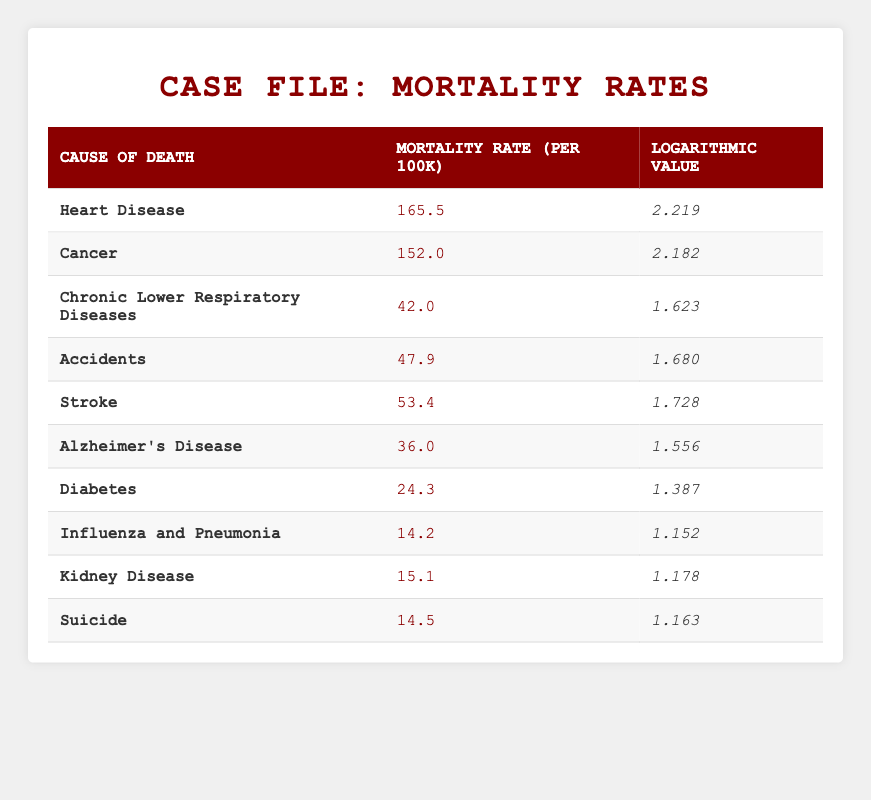What is the mortality rate for Heart Disease? The table lists the mortality rate for Heart Disease under the "Mortality Rate (per 100k)" column, which shows a value of 165.5.
Answer: 165.5 Which cause of death has the lowest mortality rate? By examining the "Mortality Rate (per 100k)" column, the lowest value is 14.2, which corresponds to Influenza and Pneumonia.
Answer: Influenza and Pneumonia Is the mortality rate for Cancer higher than that for Chronic Lower Respiratory Diseases? Yes, the table shows a mortality rate of 152.0 for Cancer and 42.0 for Chronic Lower Respiratory Diseases, indicating Cancer has a higher rate.
Answer: Yes What is the difference in mortality rates between Accidents and Stroke? The mortality rate for Accidents is 47.9 and for Stroke is 53.4. The difference is calculated as 53.4 - 47.9 = 5.5.
Answer: 5.5 What is the average mortality rate for Alzheimer's Disease and Kidney Disease? The rates for Alzheimer's Disease and Kidney Disease are 36.0 and 15.1, respectively. To find the average, the sum is 36.0 + 15.1 = 51.1, and then divided by 2 gives 51.1 / 2 = 25.55.
Answer: 25.55 Which cause of death has a logarithmic value greater than 1.7? Looking at the "Logarithmic Value" column, the causes Heart Disease (2.219), Cancer (2.182), and Stroke (1.728) have values greater than 1.7.
Answer: Heart Disease, Cancer, Stroke What is the cause of death with a mortality rate closest to 15? By checking the "Mortality Rate (per 100k)" column, Kidney Disease (15.1) is the closest to 15 when comparing all values listed.
Answer: Kidney Disease Is the combined mortality rate for Diabetes and Alzheimer's Disease greater than 60? The mortality rates for Diabetes and Alzheimer's Disease are 24.3 and 36.0, respectively. Combining these gives 24.3 + 36.0 = 60.3, which is greater than 60.
Answer: Yes How many causes of death have a logarithmic value below 1.6? The logarithmic values below 1.6 are for Alzheimer's Disease (1.556), Diabetes (1.387), Influenza and Pneumonia (1.152), Kidney Disease (1.178), and Suicide (1.163). Therefore, there are 5 such causes.
Answer: 5 